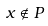<formula> <loc_0><loc_0><loc_500><loc_500>x \notin P</formula> 